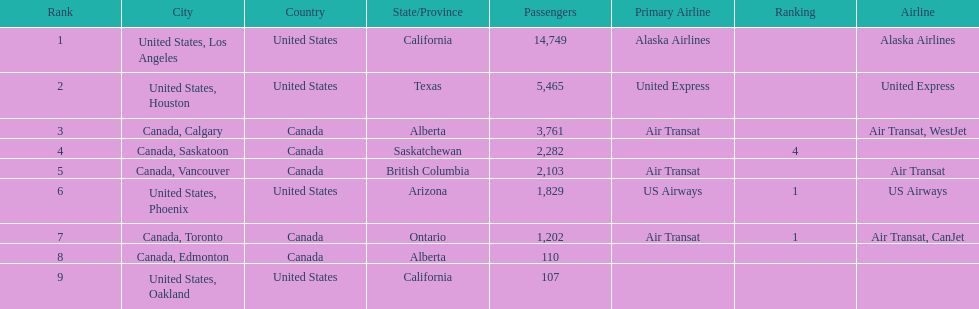What cities do the planes fly to? United States, Los Angeles, United States, Houston, Canada, Calgary, Canada, Saskatoon, Canada, Vancouver, United States, Phoenix, Canada, Toronto, Canada, Edmonton, United States, Oakland. How many people are flying to phoenix, arizona? 1,829. 